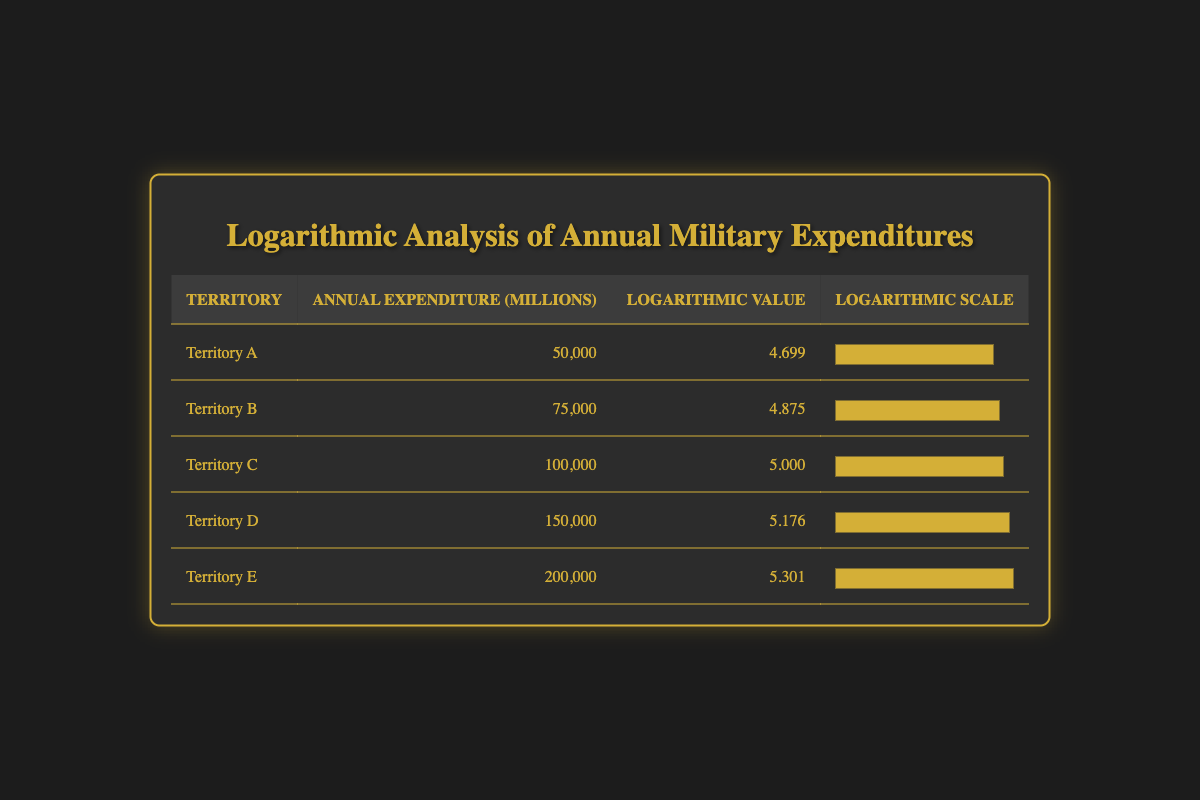What is the annual military expenditure of Territory C? The table explicitly lists the annual military expenditure for Territory C as 100,000 million.
Answer: 100,000 Which territory has the highest logarithmic value? From the table, comparing the logarithmic values, Territory E has the highest value of 5.301.
Answer: Territory E What is the difference in annual military expenditure between Territory D and Territory A? The annual military expenditure for Territory D is 150,000 million and for Territory A is 50,000 million. The difference is calculated as 150,000 - 50,000 = 100,000 million.
Answer: 100,000 Is the logarithmic value of Territory B greater than 4.8? The logarithmic value for Territory B is 4.875, which is indeed greater than 4.8, thus the answer is yes.
Answer: Yes What is the average annual military expenditure of all territories? The total expenditure is the sum of all territories: 50,000 + 75,000 + 100,000 + 150,000 + 200,000 = 575,000 million. There are 5 territories, so the average is 575,000 / 5 = 115,000 million.
Answer: 115,000 How many territories have a logarithmic value higher than 5.0? Reviewing the logarithmic values, Territories D and E have logarithmic values of 5.176 and 5.301 respectively. Therefore, there are 2 territories above 5.0.
Answer: 2 What is the ratio of the annual military expenditure of Territory E to Territory A? The expenditure for Territory E is 200,000 million and for Territory A is 50,000 million. The ratio is calculated by dividing 200,000 by 50,000, which equals 4.
Answer: 4 What is the total logarithmic value of Territories A and C combined? Territory A has a logarithmic value of 4.699 and Territory C has a value of 5.000. The total is calculated as 4.699 + 5.000 = 9.699.
Answer: 9.699 Are there any territories with an annual military expenditure exceeding 150,000 million? By examining the table, we find that Territory E has an annual expenditure of 200,000 million, which exceeds 150,000 million. Thus, the answer is yes.
Answer: Yes 